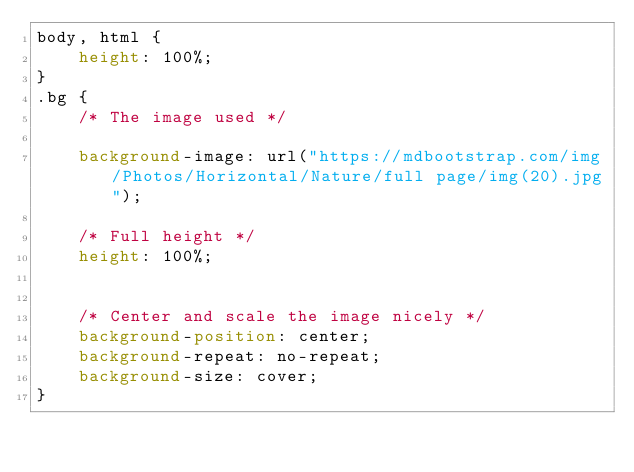Convert code to text. <code><loc_0><loc_0><loc_500><loc_500><_CSS_>body, html {
	height: 100%;
}
.bg {
	/* The image used */

	background-image: url("https://mdbootstrap.com/img/Photos/Horizontal/Nature/full page/img(20).jpg");

	/* Full height */
	height: 100%;


	/* Center and scale the image nicely */
	background-position: center;
	background-repeat: no-repeat;
	background-size: cover;
}</code> 